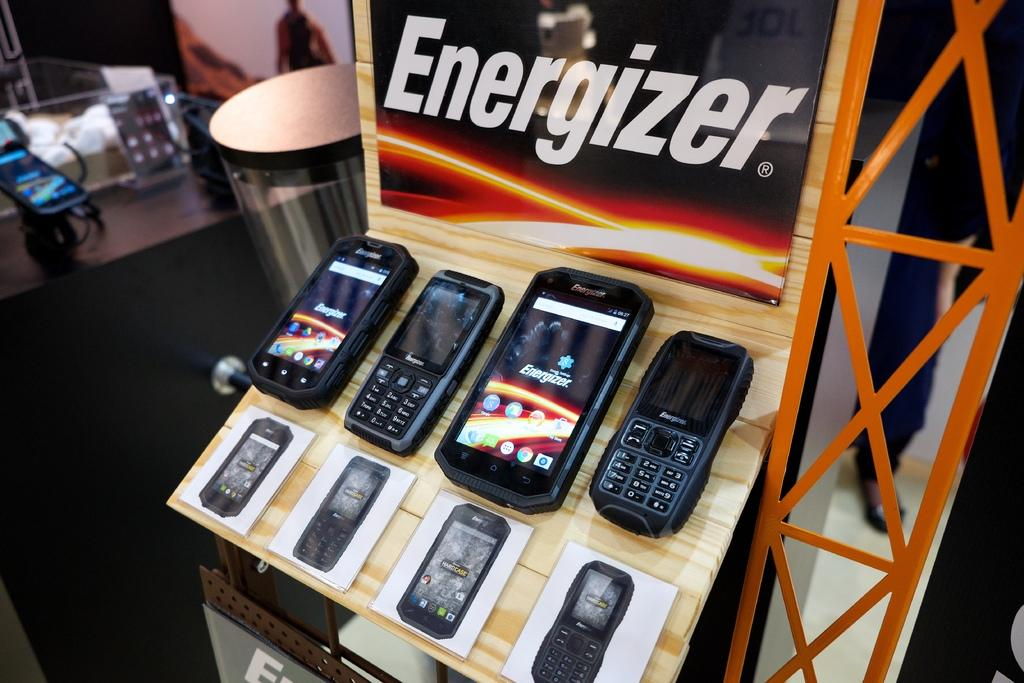What is displayed on the shelf in the image? There are mobiles arranged on a shelf in the image. What is located beside the mobiles on the shelf? There is a poster beside the mobiles on the shelf. What can be seen in the background of the image? There is a table in the background. What is on the table in the image? There is a mobile and other objects on the table. What type of steel is used to make the mobiles in the image? There is no information about the materials used to make the mobiles in the image, and there is no mention of steel. How much salt is present on the table in the image? There is no salt visible on the table in the image. 